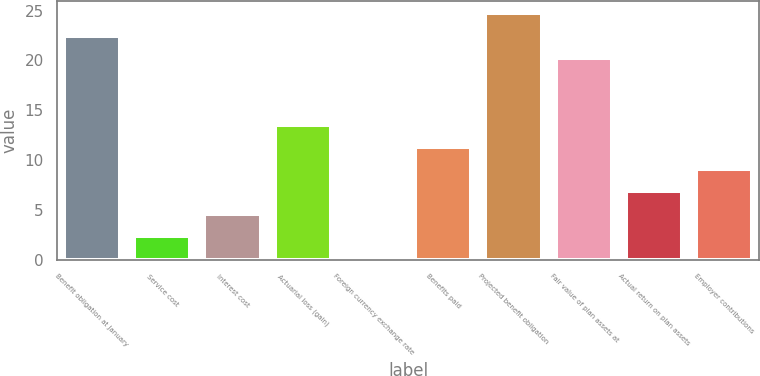<chart> <loc_0><loc_0><loc_500><loc_500><bar_chart><fcel>Benefit obligation at January<fcel>Service cost<fcel>Interest cost<fcel>Actuarial loss (gain)<fcel>Foreign currency exchange rate<fcel>Benefits paid<fcel>Projected benefit obligation<fcel>Fair value of plan assets at<fcel>Actual return on plan assets<fcel>Employer contributions<nl><fcel>22.5<fcel>2.43<fcel>4.66<fcel>13.58<fcel>0.2<fcel>11.35<fcel>24.73<fcel>20.27<fcel>6.89<fcel>9.12<nl></chart> 